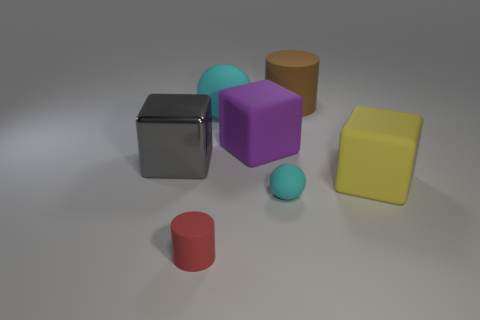What number of other matte spheres have the same color as the big matte ball?
Ensure brevity in your answer.  1. Are there an equal number of purple rubber objects that are on the left side of the small red matte cylinder and yellow shiny objects?
Ensure brevity in your answer.  Yes. There is a purple rubber thing; what shape is it?
Make the answer very short. Cube. Is there anything else that is the same color as the tiny cylinder?
Your answer should be very brief. No. There is a matte cube that is to the left of the big cylinder; is its size the same as the cyan thing to the left of the purple matte thing?
Ensure brevity in your answer.  Yes. What is the shape of the tiny object left of the large rubber block that is on the left side of the yellow matte cube?
Your answer should be very brief. Cylinder. There is a metallic object; is its size the same as the object that is on the right side of the brown thing?
Your answer should be compact. Yes. How big is the cylinder that is on the left side of the matte cylinder right of the rubber cylinder in front of the purple matte cube?
Make the answer very short. Small. How many objects are cylinders that are behind the yellow rubber cube or tiny cyan matte cubes?
Offer a very short reply. 1. How many tiny red things are on the right side of the block to the right of the large brown rubber thing?
Provide a short and direct response. 0. 